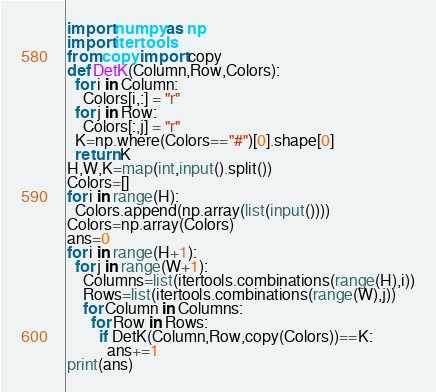<code> <loc_0><loc_0><loc_500><loc_500><_Python_>import numpy as np
import itertools
from copy import copy
def DetK(Column,Row,Colors):
  for i in Column:
    Colors[i,:] = "r"
  for j in Row:
    Colors[:,j] = "r"
  K=np.where(Colors=="#")[0].shape[0]
  return K
H,W,K=map(int,input().split())
Colors=[]
for i in range(H):
  Colors.append(np.array(list(input())))
Colors=np.array(Colors)
ans=0
for i in range(H+1):
  for j in range(W+1):
    Columns=list(itertools.combinations(range(H),i))
    Rows=list(itertools.combinations(range(W),j))
    for Column in Columns:
      for Row in Rows:
        if DetK(Column,Row,copy(Colors))==K:
          ans+=1
print(ans)
</code> 